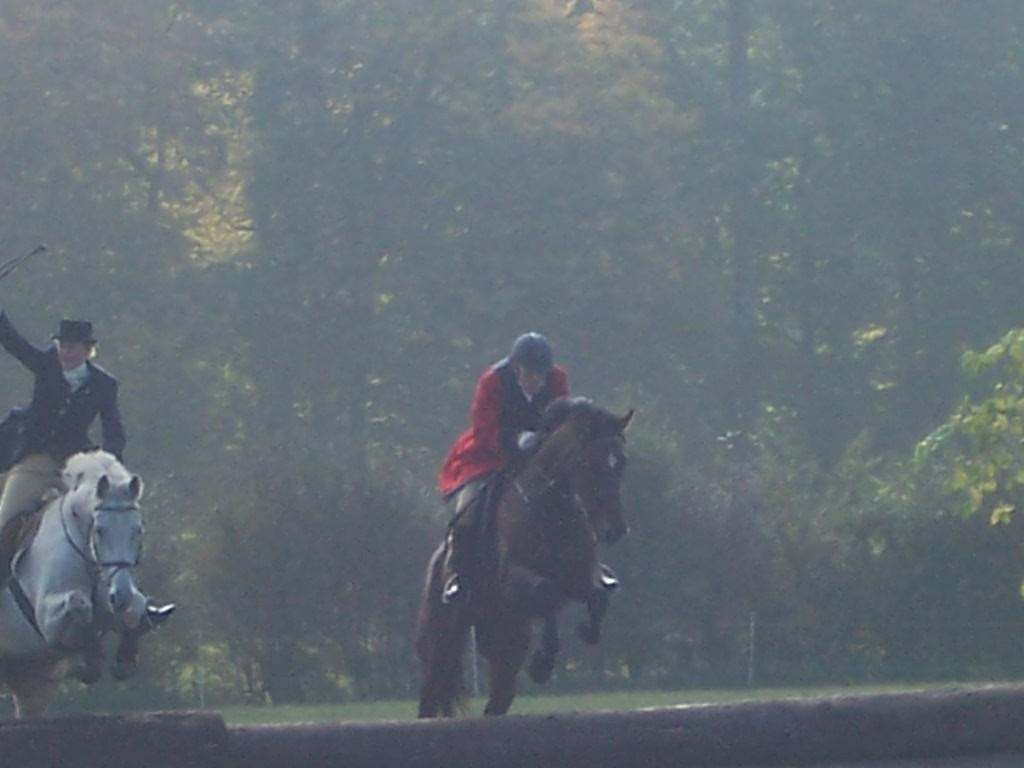How many jockeys are in the image? There are two jockeys in the image. What are the jockeys doing in the image? The jockeys are riding horses in the image. What can be seen in the background of the image? There are trees in the background of the image. What type of stamp can be seen on the horse's saddle in the image? There is no stamp visible on the horse's saddle in the image. How many eggs are being carried by the jockeys in the image? There are no eggs present in the image; the jockeys are riding horses. 